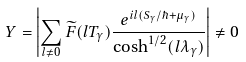Convert formula to latex. <formula><loc_0><loc_0><loc_500><loc_500>Y = \left | \sum _ { l \neq 0 } \widetilde { F } ( l T _ { \gamma } ) \frac { e ^ { i l ( S _ { \gamma } / \hbar { + } \mu _ { \gamma } ) } } { \cosh ^ { 1 / 2 } ( l \lambda _ { \gamma } ) } \right | \neq 0</formula> 